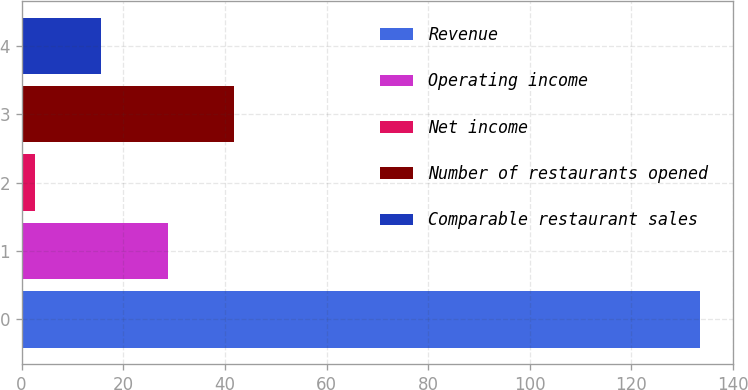Convert chart. <chart><loc_0><loc_0><loc_500><loc_500><bar_chart><fcel>Revenue<fcel>Operating income<fcel>Net income<fcel>Number of restaurants opened<fcel>Comparable restaurant sales<nl><fcel>133.4<fcel>28.76<fcel>2.6<fcel>41.84<fcel>15.68<nl></chart> 